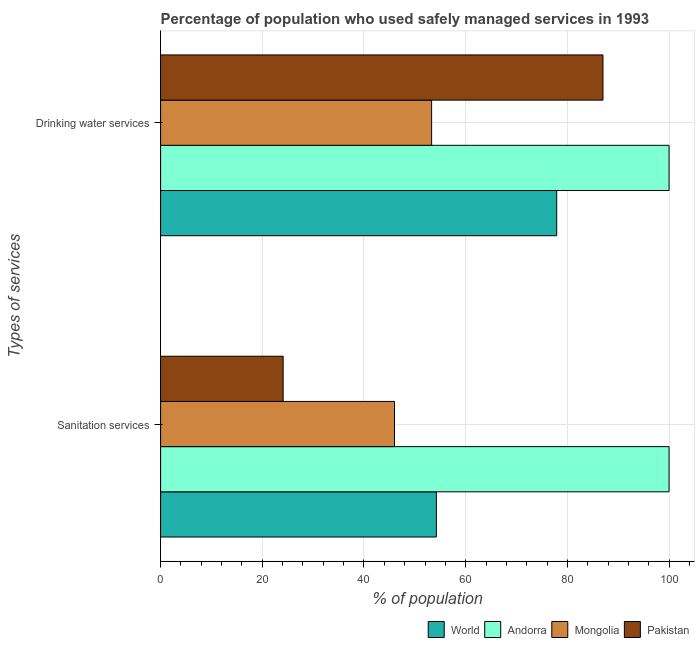How many groups of bars are there?
Offer a terse response. 2. Are the number of bars per tick equal to the number of legend labels?
Ensure brevity in your answer.  Yes. Are the number of bars on each tick of the Y-axis equal?
Your answer should be compact. Yes. How many bars are there on the 1st tick from the bottom?
Provide a succinct answer. 4. What is the label of the 2nd group of bars from the top?
Give a very brief answer. Sanitation services. What is the percentage of population who used sanitation services in Andorra?
Offer a very short reply. 100. Across all countries, what is the maximum percentage of population who used drinking water services?
Your response must be concise. 100. Across all countries, what is the minimum percentage of population who used sanitation services?
Give a very brief answer. 24.1. In which country was the percentage of population who used drinking water services maximum?
Your answer should be compact. Andorra. In which country was the percentage of population who used sanitation services minimum?
Keep it short and to the point. Pakistan. What is the total percentage of population who used sanitation services in the graph?
Make the answer very short. 224.33. What is the difference between the percentage of population who used sanitation services in Andorra and that in World?
Your response must be concise. 45.77. What is the difference between the percentage of population who used sanitation services in Andorra and the percentage of population who used drinking water services in World?
Provide a succinct answer. 22.09. What is the average percentage of population who used sanitation services per country?
Keep it short and to the point. 56.08. What is the difference between the percentage of population who used drinking water services and percentage of population who used sanitation services in Mongolia?
Your answer should be very brief. 7.3. What is the ratio of the percentage of population who used drinking water services in Andorra to that in World?
Offer a terse response. 1.28. Is the percentage of population who used drinking water services in World less than that in Mongolia?
Your answer should be very brief. No. What does the 2nd bar from the top in Sanitation services represents?
Offer a terse response. Mongolia. How many bars are there?
Your response must be concise. 8. Are all the bars in the graph horizontal?
Your response must be concise. Yes. Does the graph contain grids?
Make the answer very short. Yes. How are the legend labels stacked?
Provide a short and direct response. Horizontal. What is the title of the graph?
Your answer should be compact. Percentage of population who used safely managed services in 1993. What is the label or title of the X-axis?
Your answer should be very brief. % of population. What is the label or title of the Y-axis?
Keep it short and to the point. Types of services. What is the % of population in World in Sanitation services?
Ensure brevity in your answer.  54.23. What is the % of population in Pakistan in Sanitation services?
Keep it short and to the point. 24.1. What is the % of population of World in Drinking water services?
Ensure brevity in your answer.  77.91. What is the % of population in Mongolia in Drinking water services?
Keep it short and to the point. 53.3. What is the % of population of Pakistan in Drinking water services?
Provide a succinct answer. 87. Across all Types of services, what is the maximum % of population of World?
Provide a succinct answer. 77.91. Across all Types of services, what is the maximum % of population of Mongolia?
Your answer should be compact. 53.3. Across all Types of services, what is the maximum % of population of Pakistan?
Offer a terse response. 87. Across all Types of services, what is the minimum % of population in World?
Offer a very short reply. 54.23. Across all Types of services, what is the minimum % of population of Pakistan?
Offer a very short reply. 24.1. What is the total % of population in World in the graph?
Make the answer very short. 132.13. What is the total % of population in Andorra in the graph?
Keep it short and to the point. 200. What is the total % of population in Mongolia in the graph?
Provide a short and direct response. 99.3. What is the total % of population in Pakistan in the graph?
Offer a very short reply. 111.1. What is the difference between the % of population of World in Sanitation services and that in Drinking water services?
Offer a terse response. -23.68. What is the difference between the % of population in Pakistan in Sanitation services and that in Drinking water services?
Your answer should be very brief. -62.9. What is the difference between the % of population in World in Sanitation services and the % of population in Andorra in Drinking water services?
Make the answer very short. -45.77. What is the difference between the % of population in World in Sanitation services and the % of population in Mongolia in Drinking water services?
Provide a short and direct response. 0.93. What is the difference between the % of population of World in Sanitation services and the % of population of Pakistan in Drinking water services?
Offer a terse response. -32.77. What is the difference between the % of population of Andorra in Sanitation services and the % of population of Mongolia in Drinking water services?
Your response must be concise. 46.7. What is the difference between the % of population in Mongolia in Sanitation services and the % of population in Pakistan in Drinking water services?
Offer a very short reply. -41. What is the average % of population in World per Types of services?
Your answer should be very brief. 66.07. What is the average % of population of Andorra per Types of services?
Your answer should be compact. 100. What is the average % of population in Mongolia per Types of services?
Give a very brief answer. 49.65. What is the average % of population in Pakistan per Types of services?
Keep it short and to the point. 55.55. What is the difference between the % of population of World and % of population of Andorra in Sanitation services?
Your answer should be compact. -45.77. What is the difference between the % of population in World and % of population in Mongolia in Sanitation services?
Make the answer very short. 8.23. What is the difference between the % of population of World and % of population of Pakistan in Sanitation services?
Your answer should be very brief. 30.13. What is the difference between the % of population of Andorra and % of population of Pakistan in Sanitation services?
Your response must be concise. 75.9. What is the difference between the % of population of Mongolia and % of population of Pakistan in Sanitation services?
Give a very brief answer. 21.9. What is the difference between the % of population in World and % of population in Andorra in Drinking water services?
Provide a succinct answer. -22.09. What is the difference between the % of population in World and % of population in Mongolia in Drinking water services?
Give a very brief answer. 24.61. What is the difference between the % of population of World and % of population of Pakistan in Drinking water services?
Offer a very short reply. -9.09. What is the difference between the % of population of Andorra and % of population of Mongolia in Drinking water services?
Keep it short and to the point. 46.7. What is the difference between the % of population of Andorra and % of population of Pakistan in Drinking water services?
Provide a succinct answer. 13. What is the difference between the % of population in Mongolia and % of population in Pakistan in Drinking water services?
Ensure brevity in your answer.  -33.7. What is the ratio of the % of population in World in Sanitation services to that in Drinking water services?
Ensure brevity in your answer.  0.7. What is the ratio of the % of population of Andorra in Sanitation services to that in Drinking water services?
Your answer should be very brief. 1. What is the ratio of the % of population in Mongolia in Sanitation services to that in Drinking water services?
Provide a short and direct response. 0.86. What is the ratio of the % of population in Pakistan in Sanitation services to that in Drinking water services?
Offer a terse response. 0.28. What is the difference between the highest and the second highest % of population of World?
Provide a succinct answer. 23.68. What is the difference between the highest and the second highest % of population in Pakistan?
Give a very brief answer. 62.9. What is the difference between the highest and the lowest % of population in World?
Offer a terse response. 23.68. What is the difference between the highest and the lowest % of population in Mongolia?
Keep it short and to the point. 7.3. What is the difference between the highest and the lowest % of population in Pakistan?
Give a very brief answer. 62.9. 